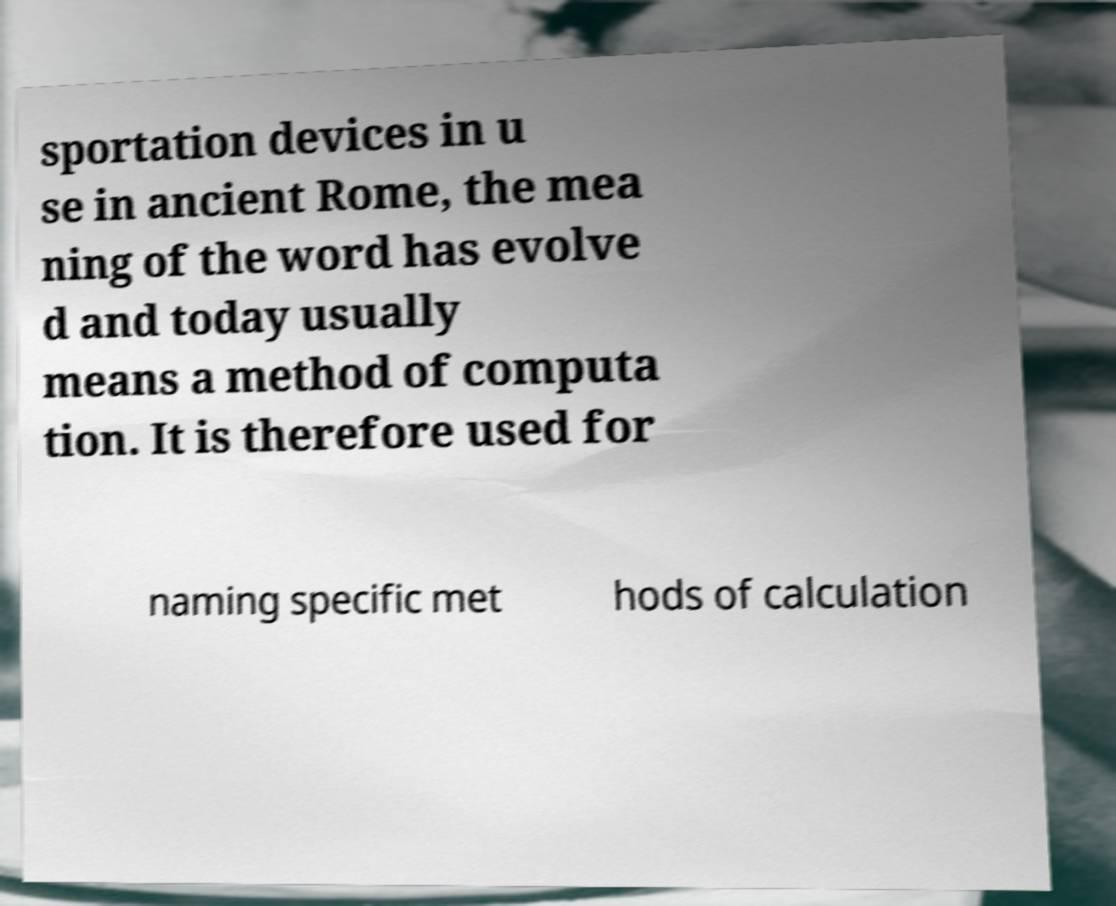Can you read and provide the text displayed in the image?This photo seems to have some interesting text. Can you extract and type it out for me? sportation devices in u se in ancient Rome, the mea ning of the word has evolve d and today usually means a method of computa tion. It is therefore used for naming specific met hods of calculation 